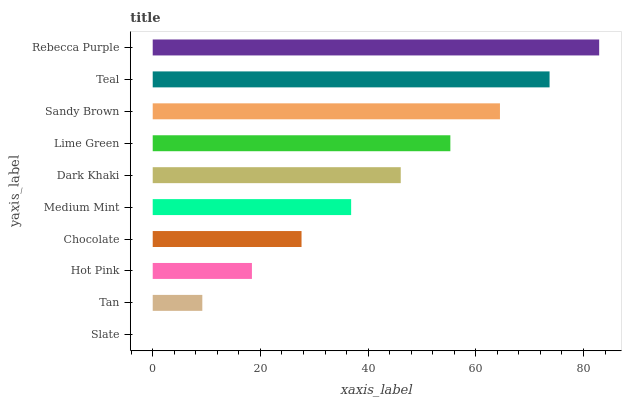Is Slate the minimum?
Answer yes or no. Yes. Is Rebecca Purple the maximum?
Answer yes or no. Yes. Is Tan the minimum?
Answer yes or no. No. Is Tan the maximum?
Answer yes or no. No. Is Tan greater than Slate?
Answer yes or no. Yes. Is Slate less than Tan?
Answer yes or no. Yes. Is Slate greater than Tan?
Answer yes or no. No. Is Tan less than Slate?
Answer yes or no. No. Is Dark Khaki the high median?
Answer yes or no. Yes. Is Medium Mint the low median?
Answer yes or no. Yes. Is Medium Mint the high median?
Answer yes or no. No. Is Tan the low median?
Answer yes or no. No. 